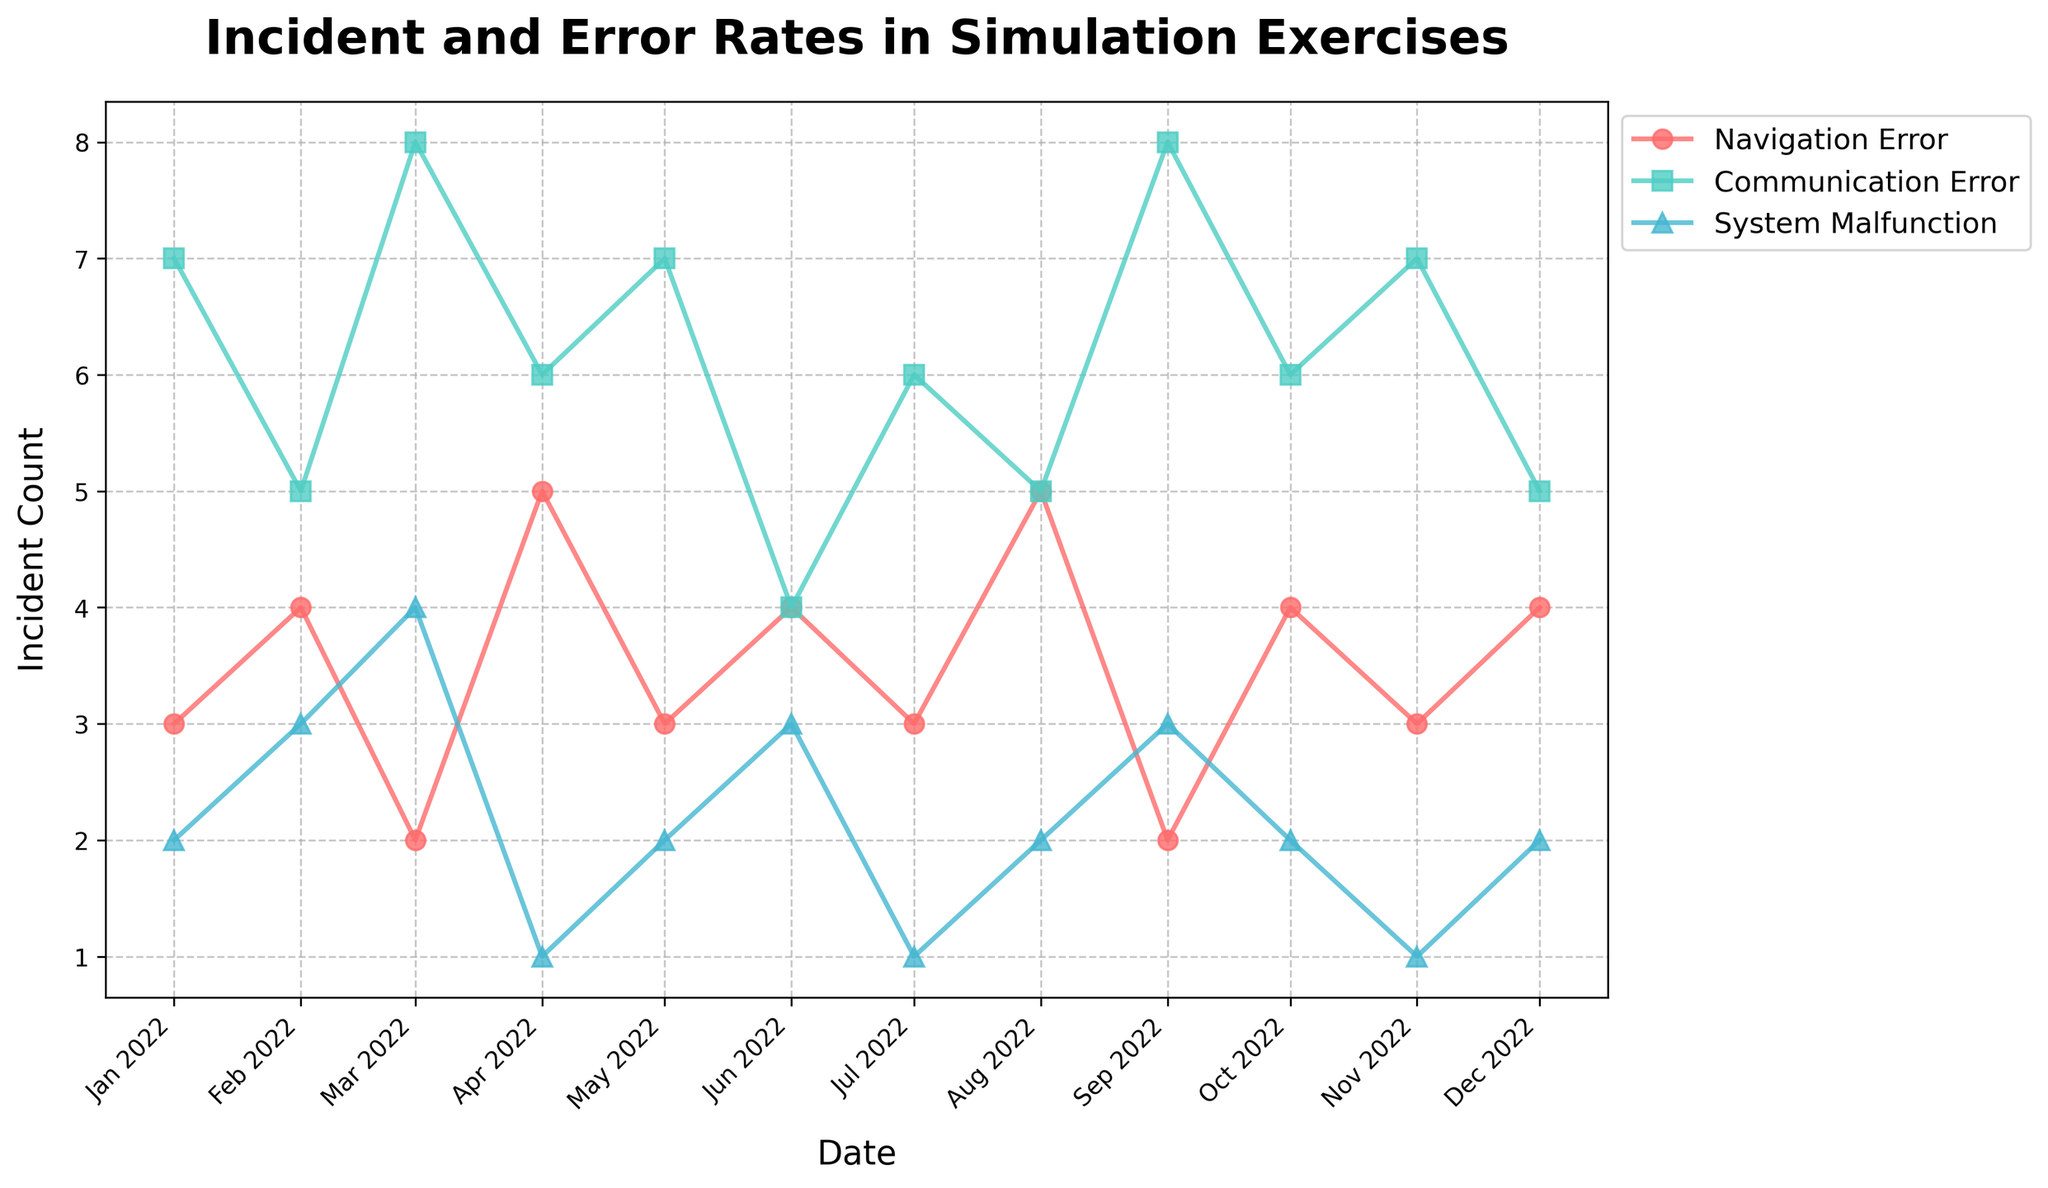what is the title of the figure? The title of the figure is prominently displayed at the top and reads "Incident and Error Rates in Simulation Exercises". This is the text that describes what the plot is depicting.
Answer: Incident and Error Rates in Simulation Exercises How many types of errors are represented in the plot? The plot legend shows different error types with their associated colors and markers. By counting these, you can see there are three types of errors represented: Navigation Error, Communication Error, and System Malfunction.
Answer: 3 Which error type had the highest incident count in January 2022? By looking at the markers and their corresponding values for January 2022, you can see that the Communication Error had the highest incident count of 7.
Answer: Communication Error What error type experienced the highest incident count increase between March 2022 and April 2022? By comparing the incident counts in March and April for each error type, Navigation Error increased from 2 to 5, which is the highest increase by 3 incidents.
Answer: Navigation Error How did the incident count of System Malfunction compare between June and November 2022? By checking the markers for System Malfunction in both June and November, you can see the incident count remained the same at 1 for both months.
Answer: Same What is the trend for Navigation Error incidents from January to December 2022? Observing the markers for Navigation Error across all months shows fluctuations but no clear upward or downward trend. The counts range between 2 and 5 throughout the year.
Answer: Fluctuating Which month had the lowest total incident count across all error types? To determine the total incident count for each month, sum the incident counts for all error types per month. March and July both have totals of 14 (Navigation: 2, Communication: 8, System: 4 for March and 3, 6, 1 for July) which are the lowest.
Answer: March and July What is the average monthly incident count for Communication Errors in 2022? Calculate the total incident count for Communication Errors from January to December, which is 74, and divide by 12 months (74/12), giving an average of 6.17.
Answer: 6.17 Compare the incident count of Communication Errors in August and October 2022. Which month had a higher count? By looking at the markers for Communication Errors in August and October, you can see that both months have the same incident count of 6.
Answer: Same 